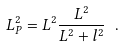<formula> <loc_0><loc_0><loc_500><loc_500>L ^ { 2 } _ { P } = L ^ { 2 } \frac { L ^ { 2 } } { L ^ { 2 } + l ^ { 2 } } \ .</formula> 